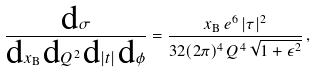Convert formula to latex. <formula><loc_0><loc_0><loc_500><loc_500>\frac { \text {d} \sigma } { \text {d} x _ { \text {B} } \, \text {d} Q ^ { 2 } \, \text {d} | t | \, \text {d} \phi } = \frac { x _ { \text {B} } \, e ^ { 6 } \, | \tau | ^ { 2 } } { 3 2 ( 2 \pi ) ^ { 4 } \, Q ^ { 4 } \, \sqrt { 1 + \epsilon ^ { 2 } } } \, ,</formula> 